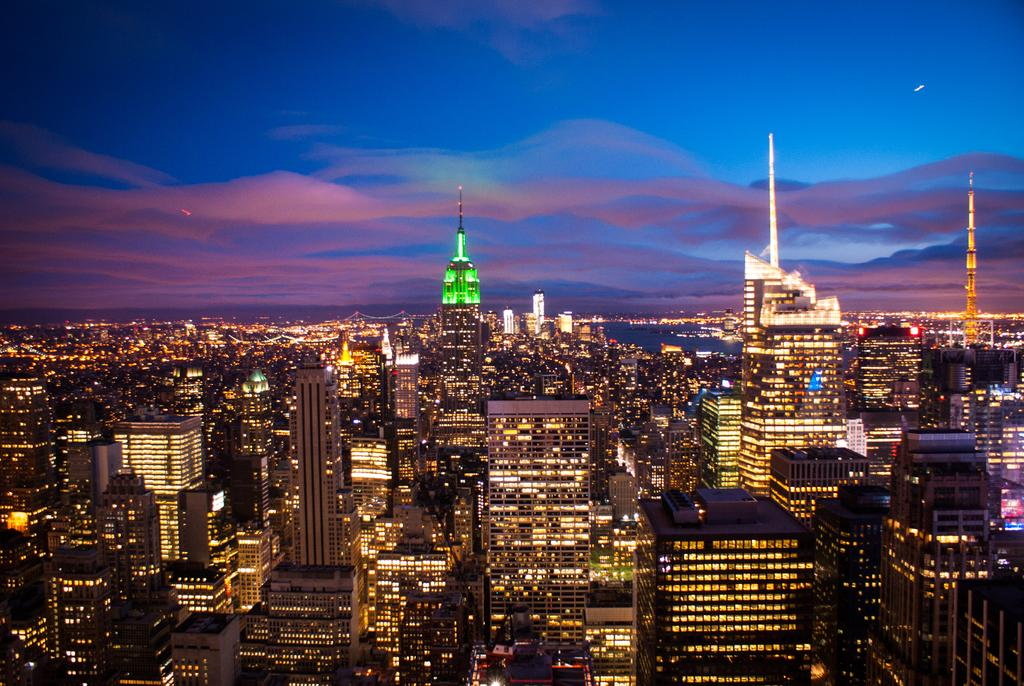What type of location is depicted in the image? The image is of a city. What structures can be seen in the city? There are buildings in the image. Can you describe the interior of the buildings? There are lights inside the buildings. What is visible at the top of the image? The sky is visible at the top of the image. What can be observed in the sky? There are clouds in the sky. What type of fang can be seen in the image? There are no fangs present in the image; it primarily focuses on the buildings and the sky. 